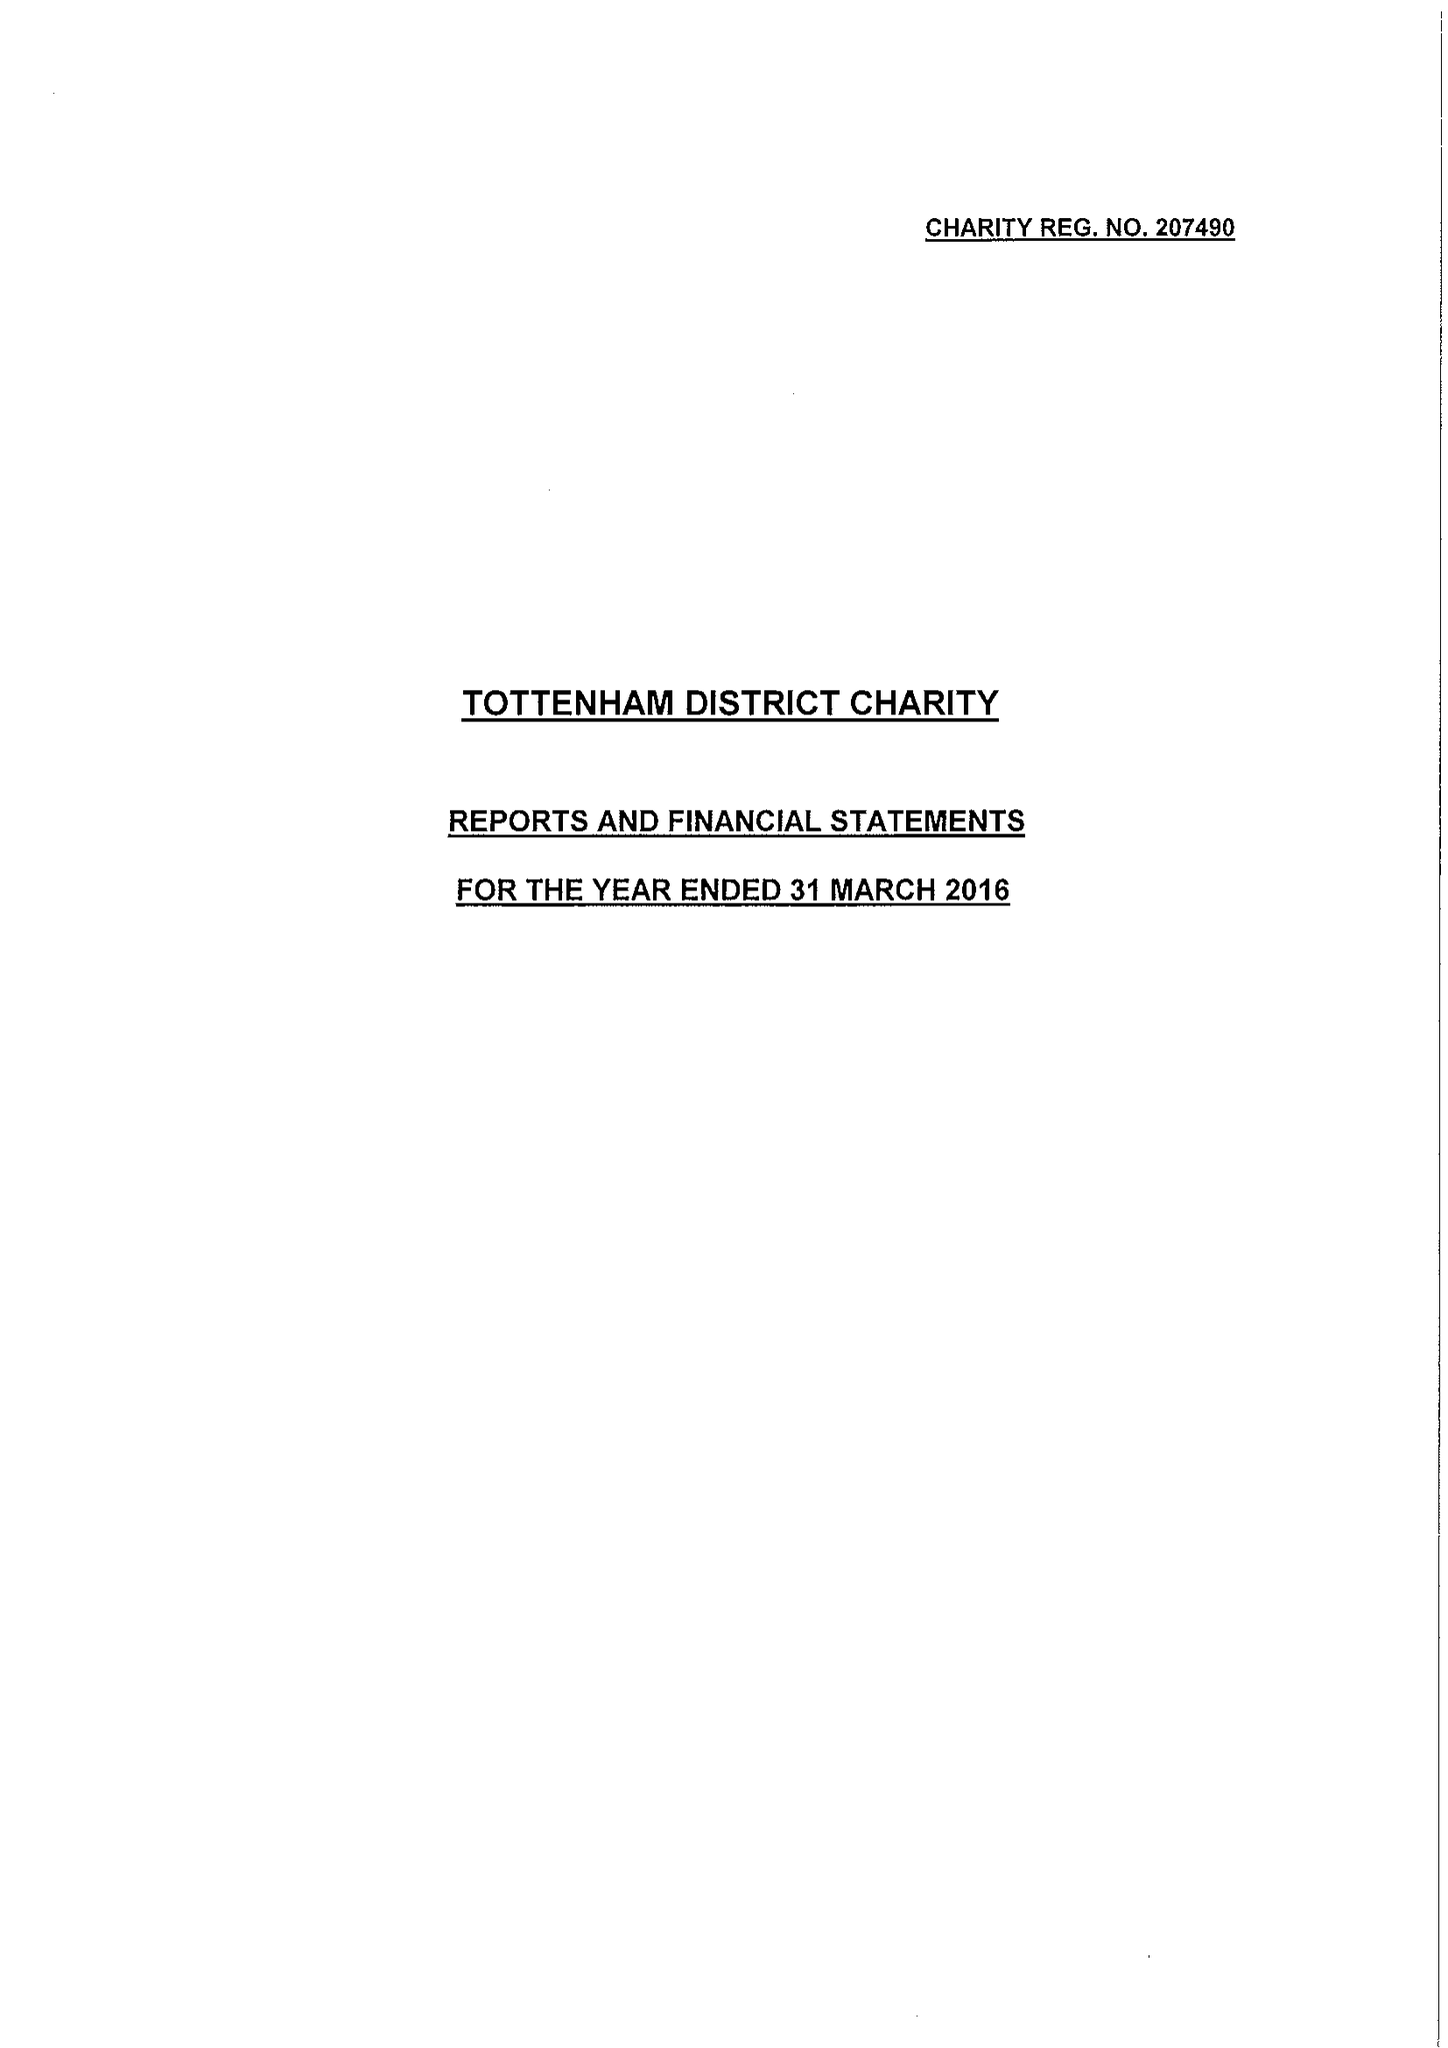What is the value for the address__postcode?
Answer the question using a single word or phrase. N22 8HQ 